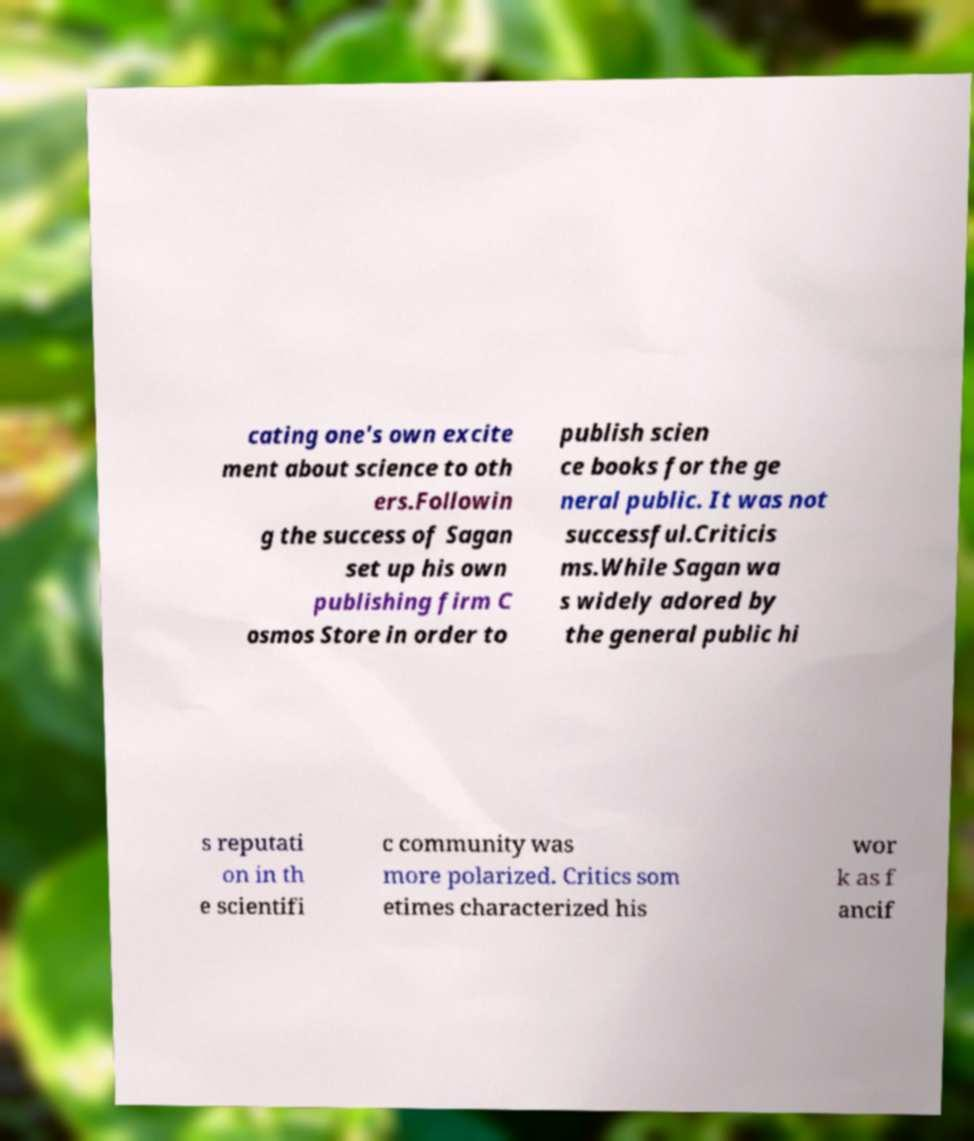Can you read and provide the text displayed in the image?This photo seems to have some interesting text. Can you extract and type it out for me? cating one's own excite ment about science to oth ers.Followin g the success of Sagan set up his own publishing firm C osmos Store in order to publish scien ce books for the ge neral public. It was not successful.Criticis ms.While Sagan wa s widely adored by the general public hi s reputati on in th e scientifi c community was more polarized. Critics som etimes characterized his wor k as f ancif 